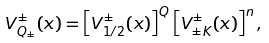<formula> <loc_0><loc_0><loc_500><loc_500>V _ { Q _ { \pm } } ^ { \pm } ( x ) = \left [ V _ { 1 / 2 } ^ { \pm } ( x ) \right ] ^ { Q } \left [ V _ { \pm K } ^ { \pm } ( x ) \right ] ^ { n } ,</formula> 